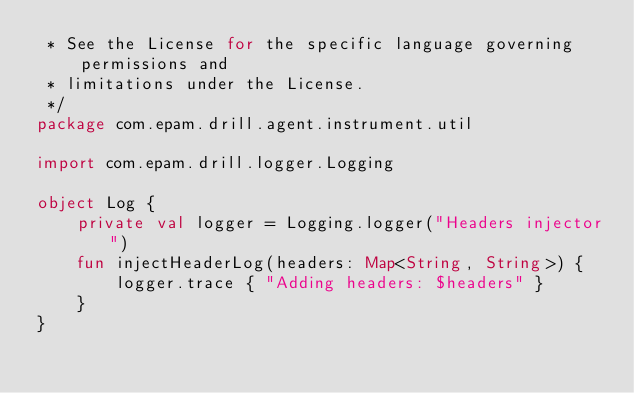<code> <loc_0><loc_0><loc_500><loc_500><_Kotlin_> * See the License for the specific language governing permissions and
 * limitations under the License.
 */
package com.epam.drill.agent.instrument.util

import com.epam.drill.logger.Logging

object Log {
    private val logger = Logging.logger("Headers injector")
    fun injectHeaderLog(headers: Map<String, String>) {
        logger.trace { "Adding headers: $headers" }
    }
}
</code> 